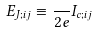Convert formula to latex. <formula><loc_0><loc_0><loc_500><loc_500>E _ { J ; i j } \equiv \frac { } { 2 e } I _ { c ; i j }</formula> 